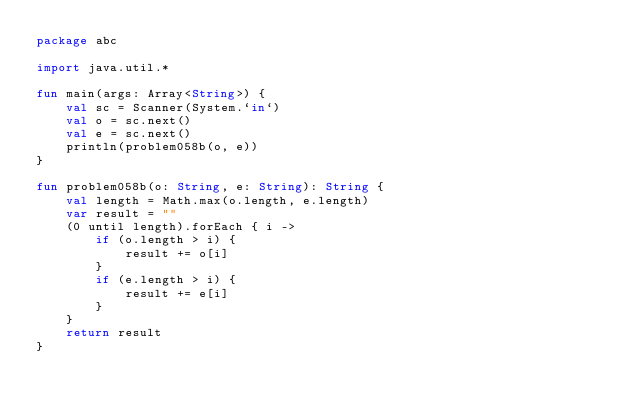<code> <loc_0><loc_0><loc_500><loc_500><_Kotlin_>package abc

import java.util.*

fun main(args: Array<String>) {
    val sc = Scanner(System.`in`)
    val o = sc.next()
    val e = sc.next()
    println(problem058b(o, e))
}

fun problem058b(o: String, e: String): String {
    val length = Math.max(o.length, e.length)
    var result = ""
    (0 until length).forEach { i ->
        if (o.length > i) {
            result += o[i]
        }
        if (e.length > i) {
            result += e[i]
        }
    }
    return result
}</code> 